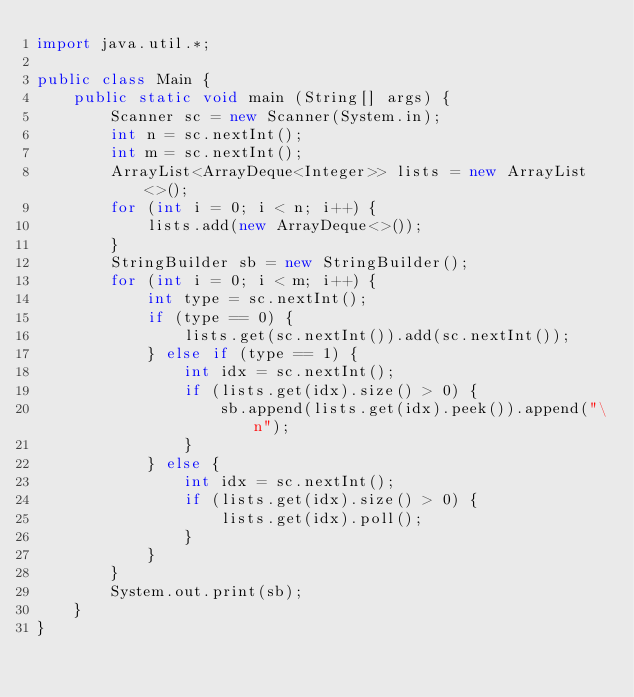<code> <loc_0><loc_0><loc_500><loc_500><_Java_>import java.util.*;

public class Main {
	public static void main (String[] args) {
		Scanner sc = new Scanner(System.in);
		int n = sc.nextInt();
		int m = sc.nextInt();
		ArrayList<ArrayDeque<Integer>> lists = new ArrayList<>();
		for (int i = 0; i < n; i++) {
		    lists.add(new ArrayDeque<>());
		}
		StringBuilder sb = new StringBuilder();
		for (int i = 0; i < m; i++) {
		    int type = sc.nextInt();
		    if (type == 0) {
		        lists.get(sc.nextInt()).add(sc.nextInt());
		    } else if (type == 1) {
		        int idx = sc.nextInt();
		        if (lists.get(idx).size() > 0) {
		            sb.append(lists.get(idx).peek()).append("\n");
		        }
		    } else {
		        int idx = sc.nextInt();
		        if (lists.get(idx).size() > 0) {
		            lists.get(idx).poll();
		        }
		    }
		}
		System.out.print(sb);
	}
}

</code> 